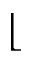<formula> <loc_0><loc_0><loc_500><loc_500>\lfloor</formula> 